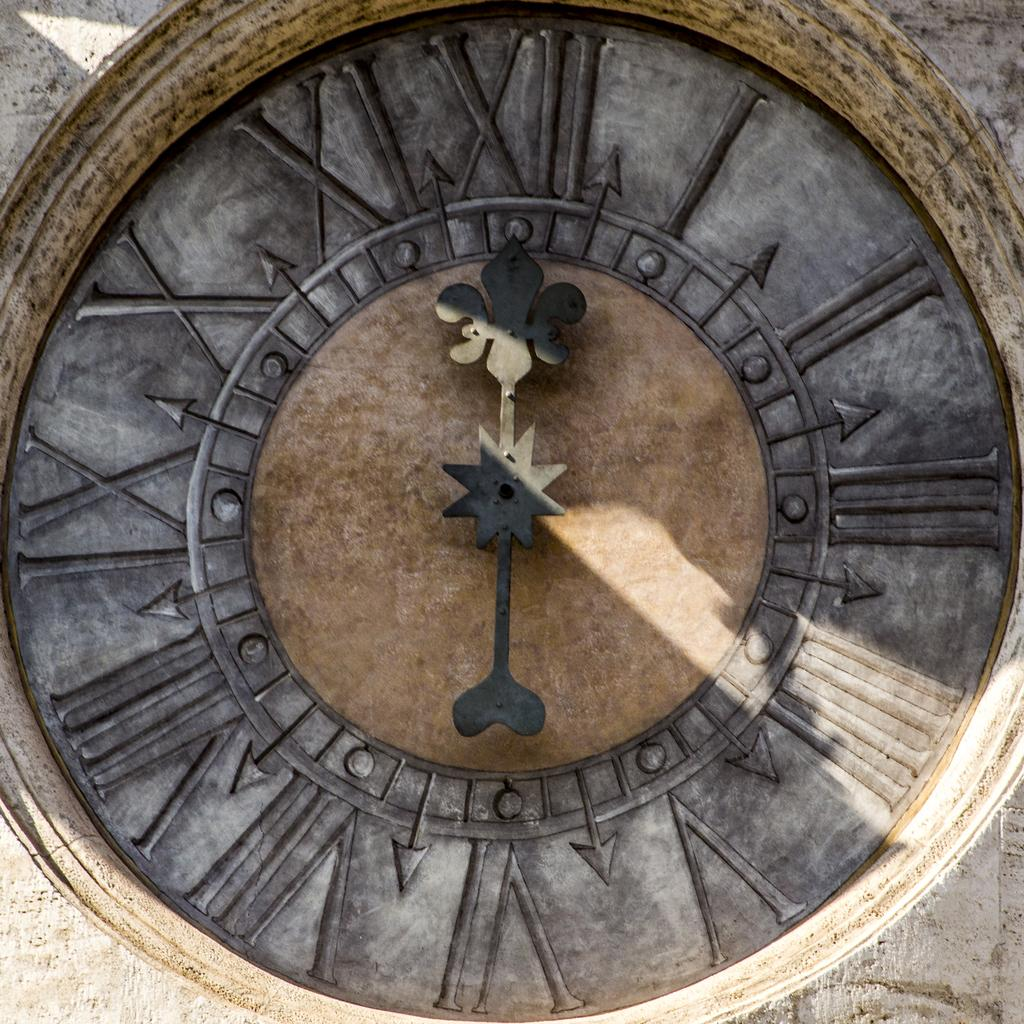What object in the image is used for measuring time? There is a clock in the image that is used for measuring time. What are the two main components of the clock? The clock has an hour hand and a minute hand. How is the clock positioned in the image? The clock is attached to a surface. What type of copper ball can be seen rolling across the yard in the image? There is no copper ball or yard present in the image; it only features a clock with an hour hand and a minute hand. 